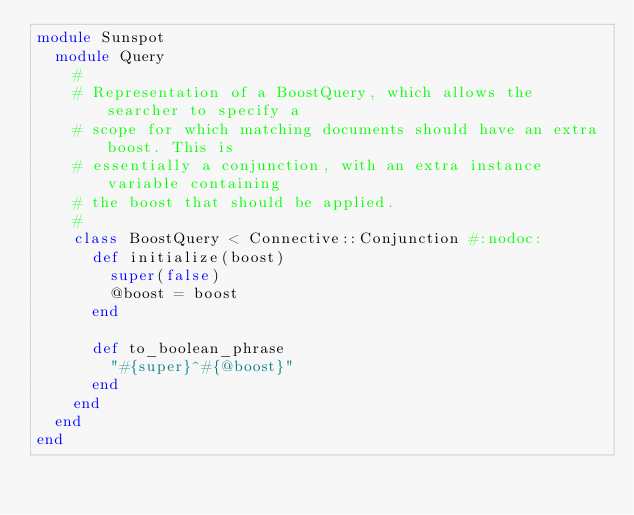<code> <loc_0><loc_0><loc_500><loc_500><_Ruby_>module Sunspot
  module Query
    # 
    # Representation of a BoostQuery, which allows the searcher to specify a
    # scope for which matching documents should have an extra boost. This is
    # essentially a conjunction, with an extra instance variable containing
    # the boost that should be applied.
    #
    class BoostQuery < Connective::Conjunction #:nodoc:
      def initialize(boost)
        super(false)
        @boost = boost
      end

      def to_boolean_phrase
        "#{super}^#{@boost}"
      end
    end
  end
end
</code> 